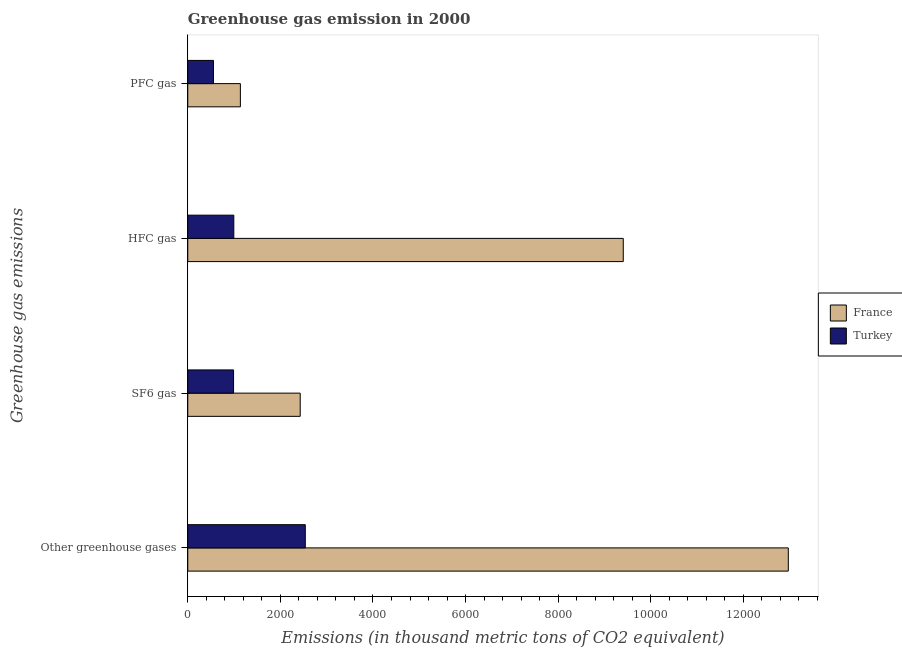How many groups of bars are there?
Give a very brief answer. 4. Are the number of bars per tick equal to the number of legend labels?
Your answer should be compact. Yes. Are the number of bars on each tick of the Y-axis equal?
Your answer should be compact. Yes. How many bars are there on the 3rd tick from the bottom?
Provide a short and direct response. 2. What is the label of the 3rd group of bars from the top?
Your answer should be compact. SF6 gas. What is the emission of greenhouse gases in France?
Keep it short and to the point. 1.30e+04. Across all countries, what is the maximum emission of pfc gas?
Make the answer very short. 1136.3. Across all countries, what is the minimum emission of sf6 gas?
Offer a very short reply. 989.2. In which country was the emission of sf6 gas maximum?
Provide a succinct answer. France. In which country was the emission of sf6 gas minimum?
Offer a very short reply. Turkey. What is the total emission of greenhouse gases in the graph?
Your response must be concise. 1.55e+04. What is the difference between the emission of greenhouse gases in France and that in Turkey?
Provide a short and direct response. 1.04e+04. What is the difference between the emission of pfc gas in Turkey and the emission of greenhouse gases in France?
Make the answer very short. -1.24e+04. What is the average emission of pfc gas per country?
Offer a very short reply. 845.6. What is the difference between the emission of hfc gas and emission of sf6 gas in Turkey?
Give a very brief answer. 5.2. In how many countries, is the emission of hfc gas greater than 10000 thousand metric tons?
Keep it short and to the point. 0. What is the ratio of the emission of greenhouse gases in France to that in Turkey?
Give a very brief answer. 5.11. Is the emission of sf6 gas in Turkey less than that in France?
Your response must be concise. Yes. What is the difference between the highest and the second highest emission of pfc gas?
Provide a short and direct response. 581.4. What is the difference between the highest and the lowest emission of pfc gas?
Provide a succinct answer. 581.4. In how many countries, is the emission of greenhouse gases greater than the average emission of greenhouse gases taken over all countries?
Provide a short and direct response. 1. Is it the case that in every country, the sum of the emission of hfc gas and emission of sf6 gas is greater than the sum of emission of pfc gas and emission of greenhouse gases?
Your response must be concise. No. Is it the case that in every country, the sum of the emission of greenhouse gases and emission of sf6 gas is greater than the emission of hfc gas?
Give a very brief answer. Yes. Are all the bars in the graph horizontal?
Your response must be concise. Yes. How many countries are there in the graph?
Offer a very short reply. 2. What is the difference between two consecutive major ticks on the X-axis?
Keep it short and to the point. 2000. Are the values on the major ticks of X-axis written in scientific E-notation?
Your answer should be very brief. No. Does the graph contain any zero values?
Give a very brief answer. No. Where does the legend appear in the graph?
Ensure brevity in your answer.  Center right. How are the legend labels stacked?
Ensure brevity in your answer.  Vertical. What is the title of the graph?
Give a very brief answer. Greenhouse gas emission in 2000. What is the label or title of the X-axis?
Make the answer very short. Emissions (in thousand metric tons of CO2 equivalent). What is the label or title of the Y-axis?
Make the answer very short. Greenhouse gas emissions. What is the Emissions (in thousand metric tons of CO2 equivalent) in France in Other greenhouse gases?
Your answer should be very brief. 1.30e+04. What is the Emissions (in thousand metric tons of CO2 equivalent) in Turkey in Other greenhouse gases?
Ensure brevity in your answer.  2538.5. What is the Emissions (in thousand metric tons of CO2 equivalent) in France in SF6 gas?
Your answer should be very brief. 2428.5. What is the Emissions (in thousand metric tons of CO2 equivalent) of Turkey in SF6 gas?
Your answer should be compact. 989.2. What is the Emissions (in thousand metric tons of CO2 equivalent) of France in HFC gas?
Keep it short and to the point. 9406.4. What is the Emissions (in thousand metric tons of CO2 equivalent) in Turkey in HFC gas?
Offer a terse response. 994.4. What is the Emissions (in thousand metric tons of CO2 equivalent) in France in PFC gas?
Offer a very short reply. 1136.3. What is the Emissions (in thousand metric tons of CO2 equivalent) of Turkey in PFC gas?
Ensure brevity in your answer.  554.9. Across all Greenhouse gas emissions, what is the maximum Emissions (in thousand metric tons of CO2 equivalent) in France?
Make the answer very short. 1.30e+04. Across all Greenhouse gas emissions, what is the maximum Emissions (in thousand metric tons of CO2 equivalent) of Turkey?
Your answer should be compact. 2538.5. Across all Greenhouse gas emissions, what is the minimum Emissions (in thousand metric tons of CO2 equivalent) of France?
Offer a very short reply. 1136.3. Across all Greenhouse gas emissions, what is the minimum Emissions (in thousand metric tons of CO2 equivalent) in Turkey?
Your response must be concise. 554.9. What is the total Emissions (in thousand metric tons of CO2 equivalent) of France in the graph?
Make the answer very short. 2.59e+04. What is the total Emissions (in thousand metric tons of CO2 equivalent) of Turkey in the graph?
Give a very brief answer. 5077. What is the difference between the Emissions (in thousand metric tons of CO2 equivalent) in France in Other greenhouse gases and that in SF6 gas?
Provide a short and direct response. 1.05e+04. What is the difference between the Emissions (in thousand metric tons of CO2 equivalent) of Turkey in Other greenhouse gases and that in SF6 gas?
Your answer should be compact. 1549.3. What is the difference between the Emissions (in thousand metric tons of CO2 equivalent) in France in Other greenhouse gases and that in HFC gas?
Provide a succinct answer. 3564.8. What is the difference between the Emissions (in thousand metric tons of CO2 equivalent) in Turkey in Other greenhouse gases and that in HFC gas?
Keep it short and to the point. 1544.1. What is the difference between the Emissions (in thousand metric tons of CO2 equivalent) in France in Other greenhouse gases and that in PFC gas?
Offer a terse response. 1.18e+04. What is the difference between the Emissions (in thousand metric tons of CO2 equivalent) in Turkey in Other greenhouse gases and that in PFC gas?
Your answer should be very brief. 1983.6. What is the difference between the Emissions (in thousand metric tons of CO2 equivalent) of France in SF6 gas and that in HFC gas?
Keep it short and to the point. -6977.9. What is the difference between the Emissions (in thousand metric tons of CO2 equivalent) in France in SF6 gas and that in PFC gas?
Provide a succinct answer. 1292.2. What is the difference between the Emissions (in thousand metric tons of CO2 equivalent) in Turkey in SF6 gas and that in PFC gas?
Ensure brevity in your answer.  434.3. What is the difference between the Emissions (in thousand metric tons of CO2 equivalent) in France in HFC gas and that in PFC gas?
Offer a terse response. 8270.1. What is the difference between the Emissions (in thousand metric tons of CO2 equivalent) in Turkey in HFC gas and that in PFC gas?
Your answer should be very brief. 439.5. What is the difference between the Emissions (in thousand metric tons of CO2 equivalent) in France in Other greenhouse gases and the Emissions (in thousand metric tons of CO2 equivalent) in Turkey in SF6 gas?
Provide a succinct answer. 1.20e+04. What is the difference between the Emissions (in thousand metric tons of CO2 equivalent) in France in Other greenhouse gases and the Emissions (in thousand metric tons of CO2 equivalent) in Turkey in HFC gas?
Your answer should be compact. 1.20e+04. What is the difference between the Emissions (in thousand metric tons of CO2 equivalent) of France in Other greenhouse gases and the Emissions (in thousand metric tons of CO2 equivalent) of Turkey in PFC gas?
Your response must be concise. 1.24e+04. What is the difference between the Emissions (in thousand metric tons of CO2 equivalent) of France in SF6 gas and the Emissions (in thousand metric tons of CO2 equivalent) of Turkey in HFC gas?
Keep it short and to the point. 1434.1. What is the difference between the Emissions (in thousand metric tons of CO2 equivalent) in France in SF6 gas and the Emissions (in thousand metric tons of CO2 equivalent) in Turkey in PFC gas?
Provide a short and direct response. 1873.6. What is the difference between the Emissions (in thousand metric tons of CO2 equivalent) in France in HFC gas and the Emissions (in thousand metric tons of CO2 equivalent) in Turkey in PFC gas?
Your answer should be compact. 8851.5. What is the average Emissions (in thousand metric tons of CO2 equivalent) of France per Greenhouse gas emissions?
Provide a succinct answer. 6485.6. What is the average Emissions (in thousand metric tons of CO2 equivalent) of Turkey per Greenhouse gas emissions?
Ensure brevity in your answer.  1269.25. What is the difference between the Emissions (in thousand metric tons of CO2 equivalent) of France and Emissions (in thousand metric tons of CO2 equivalent) of Turkey in Other greenhouse gases?
Make the answer very short. 1.04e+04. What is the difference between the Emissions (in thousand metric tons of CO2 equivalent) in France and Emissions (in thousand metric tons of CO2 equivalent) in Turkey in SF6 gas?
Offer a very short reply. 1439.3. What is the difference between the Emissions (in thousand metric tons of CO2 equivalent) of France and Emissions (in thousand metric tons of CO2 equivalent) of Turkey in HFC gas?
Offer a terse response. 8412. What is the difference between the Emissions (in thousand metric tons of CO2 equivalent) of France and Emissions (in thousand metric tons of CO2 equivalent) of Turkey in PFC gas?
Keep it short and to the point. 581.4. What is the ratio of the Emissions (in thousand metric tons of CO2 equivalent) of France in Other greenhouse gases to that in SF6 gas?
Your answer should be very brief. 5.34. What is the ratio of the Emissions (in thousand metric tons of CO2 equivalent) of Turkey in Other greenhouse gases to that in SF6 gas?
Make the answer very short. 2.57. What is the ratio of the Emissions (in thousand metric tons of CO2 equivalent) in France in Other greenhouse gases to that in HFC gas?
Offer a terse response. 1.38. What is the ratio of the Emissions (in thousand metric tons of CO2 equivalent) of Turkey in Other greenhouse gases to that in HFC gas?
Offer a terse response. 2.55. What is the ratio of the Emissions (in thousand metric tons of CO2 equivalent) in France in Other greenhouse gases to that in PFC gas?
Provide a short and direct response. 11.42. What is the ratio of the Emissions (in thousand metric tons of CO2 equivalent) of Turkey in Other greenhouse gases to that in PFC gas?
Ensure brevity in your answer.  4.57. What is the ratio of the Emissions (in thousand metric tons of CO2 equivalent) in France in SF6 gas to that in HFC gas?
Offer a very short reply. 0.26. What is the ratio of the Emissions (in thousand metric tons of CO2 equivalent) in France in SF6 gas to that in PFC gas?
Provide a succinct answer. 2.14. What is the ratio of the Emissions (in thousand metric tons of CO2 equivalent) in Turkey in SF6 gas to that in PFC gas?
Make the answer very short. 1.78. What is the ratio of the Emissions (in thousand metric tons of CO2 equivalent) of France in HFC gas to that in PFC gas?
Your response must be concise. 8.28. What is the ratio of the Emissions (in thousand metric tons of CO2 equivalent) in Turkey in HFC gas to that in PFC gas?
Offer a terse response. 1.79. What is the difference between the highest and the second highest Emissions (in thousand metric tons of CO2 equivalent) of France?
Keep it short and to the point. 3564.8. What is the difference between the highest and the second highest Emissions (in thousand metric tons of CO2 equivalent) of Turkey?
Offer a terse response. 1544.1. What is the difference between the highest and the lowest Emissions (in thousand metric tons of CO2 equivalent) in France?
Your answer should be very brief. 1.18e+04. What is the difference between the highest and the lowest Emissions (in thousand metric tons of CO2 equivalent) of Turkey?
Give a very brief answer. 1983.6. 